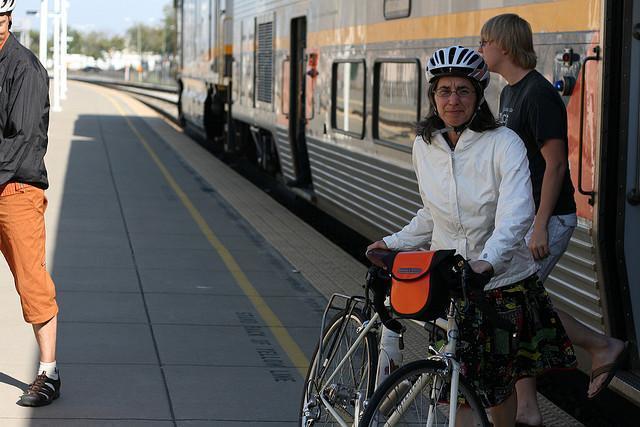How many people are holding onto a bike in this image?
Give a very brief answer. 1. How many bicycles are in the photo?
Give a very brief answer. 1. How many people are visible?
Give a very brief answer. 3. 